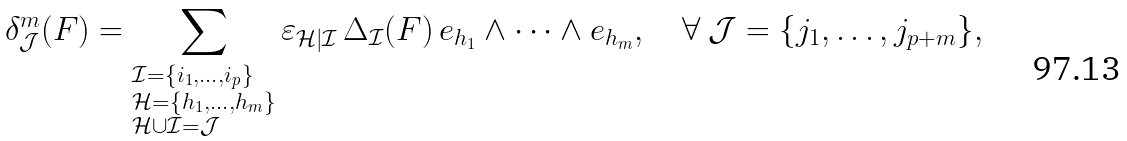<formula> <loc_0><loc_0><loc_500><loc_500>\delta ^ { m } _ { \mathcal { J } } ( F ) = \sum _ { \begin{subarray} { c } \mathcal { I } = \{ i _ { 1 } , \dots , i _ { p } \} \\ \mathcal { H } = \{ h _ { 1 } , \dots , h _ { m } \} \\ \mathcal { H } \cup \mathcal { I } = \mathcal { J } \\ \end{subarray} } \varepsilon _ { \mathcal { H } | \mathcal { I } } \, \Delta _ { \mathcal { I } } ( F ) \, e _ { h _ { 1 } } \wedge \cdots \wedge e _ { h _ { m } } , \quad \forall \ \mathcal { J } = \{ j _ { 1 } , \dots , j _ { p + m } \} ,</formula> 